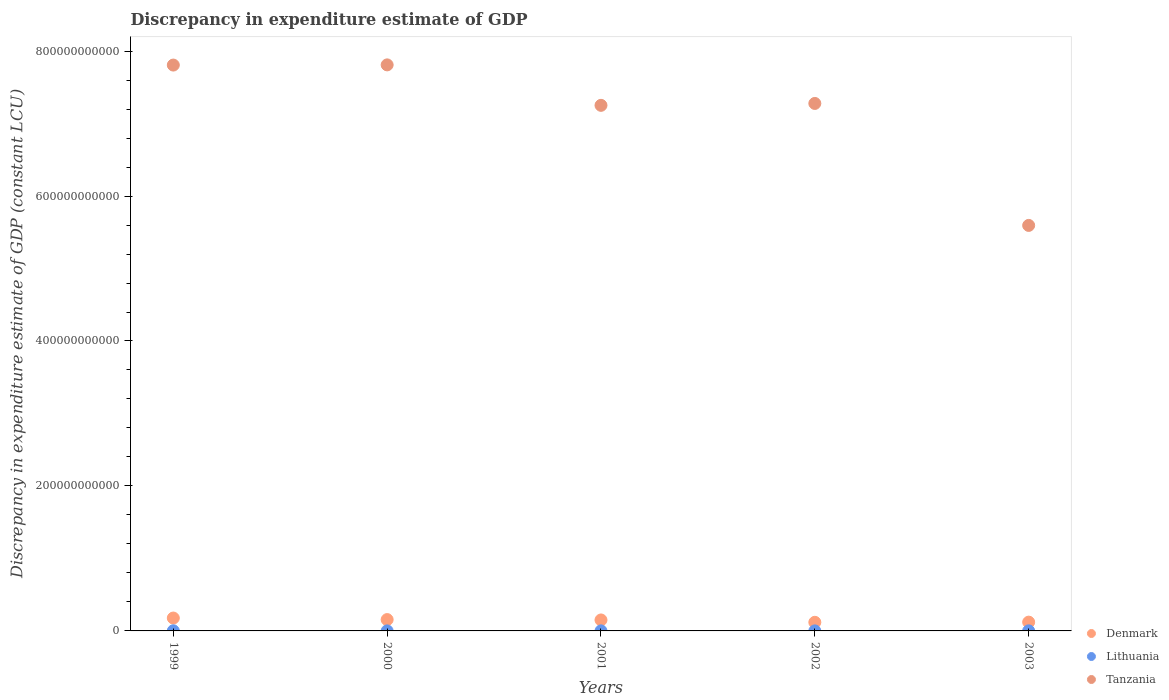How many different coloured dotlines are there?
Keep it short and to the point. 3. Is the number of dotlines equal to the number of legend labels?
Make the answer very short. Yes. What is the discrepancy in expenditure estimate of GDP in Denmark in 2002?
Provide a succinct answer. 1.19e+1. Across all years, what is the maximum discrepancy in expenditure estimate of GDP in Denmark?
Offer a terse response. 1.78e+1. Across all years, what is the minimum discrepancy in expenditure estimate of GDP in Tanzania?
Your response must be concise. 5.59e+11. What is the total discrepancy in expenditure estimate of GDP in Denmark in the graph?
Keep it short and to the point. 7.26e+1. What is the difference between the discrepancy in expenditure estimate of GDP in Lithuania in 1999 and that in 2003?
Your answer should be compact. 8.11e+07. What is the difference between the discrepancy in expenditure estimate of GDP in Denmark in 1999 and the discrepancy in expenditure estimate of GDP in Tanzania in 2001?
Your answer should be very brief. -7.07e+11. What is the average discrepancy in expenditure estimate of GDP in Denmark per year?
Give a very brief answer. 1.45e+1. In the year 2003, what is the difference between the discrepancy in expenditure estimate of GDP in Lithuania and discrepancy in expenditure estimate of GDP in Tanzania?
Offer a terse response. -5.59e+11. In how many years, is the discrepancy in expenditure estimate of GDP in Tanzania greater than 560000000000 LCU?
Provide a short and direct response. 4. What is the ratio of the discrepancy in expenditure estimate of GDP in Lithuania in 2001 to that in 2002?
Your response must be concise. 1.44. Is the discrepancy in expenditure estimate of GDP in Lithuania in 1999 less than that in 2002?
Make the answer very short. No. What is the difference between the highest and the second highest discrepancy in expenditure estimate of GDP in Tanzania?
Your response must be concise. 2.59e+08. What is the difference between the highest and the lowest discrepancy in expenditure estimate of GDP in Tanzania?
Your response must be concise. 2.21e+11. Is the sum of the discrepancy in expenditure estimate of GDP in Lithuania in 2002 and 2003 greater than the maximum discrepancy in expenditure estimate of GDP in Tanzania across all years?
Provide a short and direct response. No. Is it the case that in every year, the sum of the discrepancy in expenditure estimate of GDP in Lithuania and discrepancy in expenditure estimate of GDP in Denmark  is greater than the discrepancy in expenditure estimate of GDP in Tanzania?
Your answer should be compact. No. Does the discrepancy in expenditure estimate of GDP in Denmark monotonically increase over the years?
Ensure brevity in your answer.  No. Is the discrepancy in expenditure estimate of GDP in Denmark strictly greater than the discrepancy in expenditure estimate of GDP in Tanzania over the years?
Your answer should be very brief. No. Is the discrepancy in expenditure estimate of GDP in Tanzania strictly less than the discrepancy in expenditure estimate of GDP in Lithuania over the years?
Your answer should be compact. No. How many dotlines are there?
Offer a terse response. 3. What is the difference between two consecutive major ticks on the Y-axis?
Ensure brevity in your answer.  2.00e+11. Does the graph contain grids?
Make the answer very short. No. What is the title of the graph?
Give a very brief answer. Discrepancy in expenditure estimate of GDP. What is the label or title of the Y-axis?
Your response must be concise. Discrepancy in expenditure estimate of GDP (constant LCU). What is the Discrepancy in expenditure estimate of GDP (constant LCU) of Denmark in 1999?
Give a very brief answer. 1.78e+1. What is the Discrepancy in expenditure estimate of GDP (constant LCU) in Lithuania in 1999?
Give a very brief answer. 1.80e+08. What is the Discrepancy in expenditure estimate of GDP (constant LCU) of Tanzania in 1999?
Give a very brief answer. 7.81e+11. What is the Discrepancy in expenditure estimate of GDP (constant LCU) of Denmark in 2000?
Your answer should be compact. 1.56e+1. What is the Discrepancy in expenditure estimate of GDP (constant LCU) in Lithuania in 2000?
Offer a very short reply. 4.20e+07. What is the Discrepancy in expenditure estimate of GDP (constant LCU) of Tanzania in 2000?
Keep it short and to the point. 7.81e+11. What is the Discrepancy in expenditure estimate of GDP (constant LCU) of Denmark in 2001?
Make the answer very short. 1.51e+1. What is the Discrepancy in expenditure estimate of GDP (constant LCU) of Lithuania in 2001?
Your response must be concise. 6.81e+07. What is the Discrepancy in expenditure estimate of GDP (constant LCU) of Tanzania in 2001?
Give a very brief answer. 7.25e+11. What is the Discrepancy in expenditure estimate of GDP (constant LCU) of Denmark in 2002?
Offer a terse response. 1.19e+1. What is the Discrepancy in expenditure estimate of GDP (constant LCU) in Lithuania in 2002?
Offer a terse response. 4.74e+07. What is the Discrepancy in expenditure estimate of GDP (constant LCU) of Tanzania in 2002?
Your answer should be very brief. 7.28e+11. What is the Discrepancy in expenditure estimate of GDP (constant LCU) of Denmark in 2003?
Ensure brevity in your answer.  1.21e+1. What is the Discrepancy in expenditure estimate of GDP (constant LCU) in Lithuania in 2003?
Your answer should be compact. 9.86e+07. What is the Discrepancy in expenditure estimate of GDP (constant LCU) of Tanzania in 2003?
Your answer should be very brief. 5.59e+11. Across all years, what is the maximum Discrepancy in expenditure estimate of GDP (constant LCU) of Denmark?
Offer a very short reply. 1.78e+1. Across all years, what is the maximum Discrepancy in expenditure estimate of GDP (constant LCU) in Lithuania?
Offer a terse response. 1.80e+08. Across all years, what is the maximum Discrepancy in expenditure estimate of GDP (constant LCU) of Tanzania?
Offer a terse response. 7.81e+11. Across all years, what is the minimum Discrepancy in expenditure estimate of GDP (constant LCU) in Denmark?
Provide a short and direct response. 1.19e+1. Across all years, what is the minimum Discrepancy in expenditure estimate of GDP (constant LCU) in Lithuania?
Give a very brief answer. 4.20e+07. Across all years, what is the minimum Discrepancy in expenditure estimate of GDP (constant LCU) in Tanzania?
Provide a succinct answer. 5.59e+11. What is the total Discrepancy in expenditure estimate of GDP (constant LCU) of Denmark in the graph?
Your answer should be very brief. 7.26e+1. What is the total Discrepancy in expenditure estimate of GDP (constant LCU) in Lithuania in the graph?
Offer a terse response. 4.36e+08. What is the total Discrepancy in expenditure estimate of GDP (constant LCU) of Tanzania in the graph?
Provide a short and direct response. 3.57e+12. What is the difference between the Discrepancy in expenditure estimate of GDP (constant LCU) of Denmark in 1999 and that in 2000?
Provide a succinct answer. 2.12e+09. What is the difference between the Discrepancy in expenditure estimate of GDP (constant LCU) of Lithuania in 1999 and that in 2000?
Your response must be concise. 1.38e+08. What is the difference between the Discrepancy in expenditure estimate of GDP (constant LCU) in Tanzania in 1999 and that in 2000?
Your answer should be compact. -2.59e+08. What is the difference between the Discrepancy in expenditure estimate of GDP (constant LCU) in Denmark in 1999 and that in 2001?
Provide a succinct answer. 2.63e+09. What is the difference between the Discrepancy in expenditure estimate of GDP (constant LCU) of Lithuania in 1999 and that in 2001?
Give a very brief answer. 1.12e+08. What is the difference between the Discrepancy in expenditure estimate of GDP (constant LCU) of Tanzania in 1999 and that in 2001?
Offer a very short reply. 5.56e+1. What is the difference between the Discrepancy in expenditure estimate of GDP (constant LCU) of Denmark in 1999 and that in 2002?
Provide a short and direct response. 5.87e+09. What is the difference between the Discrepancy in expenditure estimate of GDP (constant LCU) in Lithuania in 1999 and that in 2002?
Keep it short and to the point. 1.32e+08. What is the difference between the Discrepancy in expenditure estimate of GDP (constant LCU) of Tanzania in 1999 and that in 2002?
Offer a very short reply. 5.30e+1. What is the difference between the Discrepancy in expenditure estimate of GDP (constant LCU) in Denmark in 1999 and that in 2003?
Make the answer very short. 5.64e+09. What is the difference between the Discrepancy in expenditure estimate of GDP (constant LCU) in Lithuania in 1999 and that in 2003?
Your answer should be very brief. 8.11e+07. What is the difference between the Discrepancy in expenditure estimate of GDP (constant LCU) of Tanzania in 1999 and that in 2003?
Provide a short and direct response. 2.21e+11. What is the difference between the Discrepancy in expenditure estimate of GDP (constant LCU) of Denmark in 2000 and that in 2001?
Keep it short and to the point. 5.18e+08. What is the difference between the Discrepancy in expenditure estimate of GDP (constant LCU) in Lithuania in 2000 and that in 2001?
Make the answer very short. -2.60e+07. What is the difference between the Discrepancy in expenditure estimate of GDP (constant LCU) in Tanzania in 2000 and that in 2001?
Keep it short and to the point. 5.58e+1. What is the difference between the Discrepancy in expenditure estimate of GDP (constant LCU) in Denmark in 2000 and that in 2002?
Make the answer very short. 3.76e+09. What is the difference between the Discrepancy in expenditure estimate of GDP (constant LCU) in Lithuania in 2000 and that in 2002?
Provide a short and direct response. -5.33e+06. What is the difference between the Discrepancy in expenditure estimate of GDP (constant LCU) of Tanzania in 2000 and that in 2002?
Offer a terse response. 5.32e+1. What is the difference between the Discrepancy in expenditure estimate of GDP (constant LCU) of Denmark in 2000 and that in 2003?
Give a very brief answer. 3.53e+09. What is the difference between the Discrepancy in expenditure estimate of GDP (constant LCU) of Lithuania in 2000 and that in 2003?
Your answer should be very brief. -5.65e+07. What is the difference between the Discrepancy in expenditure estimate of GDP (constant LCU) of Tanzania in 2000 and that in 2003?
Your answer should be compact. 2.21e+11. What is the difference between the Discrepancy in expenditure estimate of GDP (constant LCU) of Denmark in 2001 and that in 2002?
Your answer should be very brief. 3.24e+09. What is the difference between the Discrepancy in expenditure estimate of GDP (constant LCU) of Lithuania in 2001 and that in 2002?
Your response must be concise. 2.07e+07. What is the difference between the Discrepancy in expenditure estimate of GDP (constant LCU) of Tanzania in 2001 and that in 2002?
Offer a very short reply. -2.62e+09. What is the difference between the Discrepancy in expenditure estimate of GDP (constant LCU) of Denmark in 2001 and that in 2003?
Your response must be concise. 3.01e+09. What is the difference between the Discrepancy in expenditure estimate of GDP (constant LCU) of Lithuania in 2001 and that in 2003?
Provide a short and direct response. -3.05e+07. What is the difference between the Discrepancy in expenditure estimate of GDP (constant LCU) in Tanzania in 2001 and that in 2003?
Make the answer very short. 1.66e+11. What is the difference between the Discrepancy in expenditure estimate of GDP (constant LCU) in Denmark in 2002 and that in 2003?
Your answer should be compact. -2.29e+08. What is the difference between the Discrepancy in expenditure estimate of GDP (constant LCU) in Lithuania in 2002 and that in 2003?
Offer a terse response. -5.12e+07. What is the difference between the Discrepancy in expenditure estimate of GDP (constant LCU) in Tanzania in 2002 and that in 2003?
Your answer should be very brief. 1.68e+11. What is the difference between the Discrepancy in expenditure estimate of GDP (constant LCU) in Denmark in 1999 and the Discrepancy in expenditure estimate of GDP (constant LCU) in Lithuania in 2000?
Make the answer very short. 1.77e+1. What is the difference between the Discrepancy in expenditure estimate of GDP (constant LCU) of Denmark in 1999 and the Discrepancy in expenditure estimate of GDP (constant LCU) of Tanzania in 2000?
Provide a succinct answer. -7.63e+11. What is the difference between the Discrepancy in expenditure estimate of GDP (constant LCU) of Lithuania in 1999 and the Discrepancy in expenditure estimate of GDP (constant LCU) of Tanzania in 2000?
Provide a short and direct response. -7.81e+11. What is the difference between the Discrepancy in expenditure estimate of GDP (constant LCU) in Denmark in 1999 and the Discrepancy in expenditure estimate of GDP (constant LCU) in Lithuania in 2001?
Your answer should be very brief. 1.77e+1. What is the difference between the Discrepancy in expenditure estimate of GDP (constant LCU) in Denmark in 1999 and the Discrepancy in expenditure estimate of GDP (constant LCU) in Tanzania in 2001?
Your answer should be very brief. -7.07e+11. What is the difference between the Discrepancy in expenditure estimate of GDP (constant LCU) of Lithuania in 1999 and the Discrepancy in expenditure estimate of GDP (constant LCU) of Tanzania in 2001?
Provide a succinct answer. -7.25e+11. What is the difference between the Discrepancy in expenditure estimate of GDP (constant LCU) of Denmark in 1999 and the Discrepancy in expenditure estimate of GDP (constant LCU) of Lithuania in 2002?
Make the answer very short. 1.77e+1. What is the difference between the Discrepancy in expenditure estimate of GDP (constant LCU) in Denmark in 1999 and the Discrepancy in expenditure estimate of GDP (constant LCU) in Tanzania in 2002?
Offer a terse response. -7.10e+11. What is the difference between the Discrepancy in expenditure estimate of GDP (constant LCU) of Lithuania in 1999 and the Discrepancy in expenditure estimate of GDP (constant LCU) of Tanzania in 2002?
Your answer should be very brief. -7.28e+11. What is the difference between the Discrepancy in expenditure estimate of GDP (constant LCU) of Denmark in 1999 and the Discrepancy in expenditure estimate of GDP (constant LCU) of Lithuania in 2003?
Give a very brief answer. 1.77e+1. What is the difference between the Discrepancy in expenditure estimate of GDP (constant LCU) of Denmark in 1999 and the Discrepancy in expenditure estimate of GDP (constant LCU) of Tanzania in 2003?
Ensure brevity in your answer.  -5.42e+11. What is the difference between the Discrepancy in expenditure estimate of GDP (constant LCU) in Lithuania in 1999 and the Discrepancy in expenditure estimate of GDP (constant LCU) in Tanzania in 2003?
Offer a very short reply. -5.59e+11. What is the difference between the Discrepancy in expenditure estimate of GDP (constant LCU) of Denmark in 2000 and the Discrepancy in expenditure estimate of GDP (constant LCU) of Lithuania in 2001?
Offer a very short reply. 1.56e+1. What is the difference between the Discrepancy in expenditure estimate of GDP (constant LCU) in Denmark in 2000 and the Discrepancy in expenditure estimate of GDP (constant LCU) in Tanzania in 2001?
Make the answer very short. -7.09e+11. What is the difference between the Discrepancy in expenditure estimate of GDP (constant LCU) of Lithuania in 2000 and the Discrepancy in expenditure estimate of GDP (constant LCU) of Tanzania in 2001?
Make the answer very short. -7.25e+11. What is the difference between the Discrepancy in expenditure estimate of GDP (constant LCU) of Denmark in 2000 and the Discrepancy in expenditure estimate of GDP (constant LCU) of Lithuania in 2002?
Your response must be concise. 1.56e+1. What is the difference between the Discrepancy in expenditure estimate of GDP (constant LCU) in Denmark in 2000 and the Discrepancy in expenditure estimate of GDP (constant LCU) in Tanzania in 2002?
Give a very brief answer. -7.12e+11. What is the difference between the Discrepancy in expenditure estimate of GDP (constant LCU) in Lithuania in 2000 and the Discrepancy in expenditure estimate of GDP (constant LCU) in Tanzania in 2002?
Give a very brief answer. -7.28e+11. What is the difference between the Discrepancy in expenditure estimate of GDP (constant LCU) in Denmark in 2000 and the Discrepancy in expenditure estimate of GDP (constant LCU) in Lithuania in 2003?
Give a very brief answer. 1.55e+1. What is the difference between the Discrepancy in expenditure estimate of GDP (constant LCU) of Denmark in 2000 and the Discrepancy in expenditure estimate of GDP (constant LCU) of Tanzania in 2003?
Keep it short and to the point. -5.44e+11. What is the difference between the Discrepancy in expenditure estimate of GDP (constant LCU) in Lithuania in 2000 and the Discrepancy in expenditure estimate of GDP (constant LCU) in Tanzania in 2003?
Your response must be concise. -5.59e+11. What is the difference between the Discrepancy in expenditure estimate of GDP (constant LCU) of Denmark in 2001 and the Discrepancy in expenditure estimate of GDP (constant LCU) of Lithuania in 2002?
Offer a terse response. 1.51e+1. What is the difference between the Discrepancy in expenditure estimate of GDP (constant LCU) in Denmark in 2001 and the Discrepancy in expenditure estimate of GDP (constant LCU) in Tanzania in 2002?
Provide a short and direct response. -7.13e+11. What is the difference between the Discrepancy in expenditure estimate of GDP (constant LCU) in Lithuania in 2001 and the Discrepancy in expenditure estimate of GDP (constant LCU) in Tanzania in 2002?
Offer a terse response. -7.28e+11. What is the difference between the Discrepancy in expenditure estimate of GDP (constant LCU) in Denmark in 2001 and the Discrepancy in expenditure estimate of GDP (constant LCU) in Lithuania in 2003?
Offer a very short reply. 1.50e+1. What is the difference between the Discrepancy in expenditure estimate of GDP (constant LCU) of Denmark in 2001 and the Discrepancy in expenditure estimate of GDP (constant LCU) of Tanzania in 2003?
Keep it short and to the point. -5.44e+11. What is the difference between the Discrepancy in expenditure estimate of GDP (constant LCU) in Lithuania in 2001 and the Discrepancy in expenditure estimate of GDP (constant LCU) in Tanzania in 2003?
Your answer should be very brief. -5.59e+11. What is the difference between the Discrepancy in expenditure estimate of GDP (constant LCU) in Denmark in 2002 and the Discrepancy in expenditure estimate of GDP (constant LCU) in Lithuania in 2003?
Your response must be concise. 1.18e+1. What is the difference between the Discrepancy in expenditure estimate of GDP (constant LCU) in Denmark in 2002 and the Discrepancy in expenditure estimate of GDP (constant LCU) in Tanzania in 2003?
Offer a very short reply. -5.48e+11. What is the difference between the Discrepancy in expenditure estimate of GDP (constant LCU) of Lithuania in 2002 and the Discrepancy in expenditure estimate of GDP (constant LCU) of Tanzania in 2003?
Provide a succinct answer. -5.59e+11. What is the average Discrepancy in expenditure estimate of GDP (constant LCU) in Denmark per year?
Provide a short and direct response. 1.45e+1. What is the average Discrepancy in expenditure estimate of GDP (constant LCU) of Lithuania per year?
Offer a terse response. 8.71e+07. What is the average Discrepancy in expenditure estimate of GDP (constant LCU) in Tanzania per year?
Your answer should be very brief. 7.15e+11. In the year 1999, what is the difference between the Discrepancy in expenditure estimate of GDP (constant LCU) of Denmark and Discrepancy in expenditure estimate of GDP (constant LCU) of Lithuania?
Ensure brevity in your answer.  1.76e+1. In the year 1999, what is the difference between the Discrepancy in expenditure estimate of GDP (constant LCU) of Denmark and Discrepancy in expenditure estimate of GDP (constant LCU) of Tanzania?
Your response must be concise. -7.63e+11. In the year 1999, what is the difference between the Discrepancy in expenditure estimate of GDP (constant LCU) of Lithuania and Discrepancy in expenditure estimate of GDP (constant LCU) of Tanzania?
Ensure brevity in your answer.  -7.81e+11. In the year 2000, what is the difference between the Discrepancy in expenditure estimate of GDP (constant LCU) in Denmark and Discrepancy in expenditure estimate of GDP (constant LCU) in Lithuania?
Ensure brevity in your answer.  1.56e+1. In the year 2000, what is the difference between the Discrepancy in expenditure estimate of GDP (constant LCU) of Denmark and Discrepancy in expenditure estimate of GDP (constant LCU) of Tanzania?
Your answer should be very brief. -7.65e+11. In the year 2000, what is the difference between the Discrepancy in expenditure estimate of GDP (constant LCU) of Lithuania and Discrepancy in expenditure estimate of GDP (constant LCU) of Tanzania?
Give a very brief answer. -7.81e+11. In the year 2001, what is the difference between the Discrepancy in expenditure estimate of GDP (constant LCU) of Denmark and Discrepancy in expenditure estimate of GDP (constant LCU) of Lithuania?
Your answer should be compact. 1.51e+1. In the year 2001, what is the difference between the Discrepancy in expenditure estimate of GDP (constant LCU) in Denmark and Discrepancy in expenditure estimate of GDP (constant LCU) in Tanzania?
Offer a very short reply. -7.10e+11. In the year 2001, what is the difference between the Discrepancy in expenditure estimate of GDP (constant LCU) in Lithuania and Discrepancy in expenditure estimate of GDP (constant LCU) in Tanzania?
Keep it short and to the point. -7.25e+11. In the year 2002, what is the difference between the Discrepancy in expenditure estimate of GDP (constant LCU) of Denmark and Discrepancy in expenditure estimate of GDP (constant LCU) of Lithuania?
Provide a succinct answer. 1.18e+1. In the year 2002, what is the difference between the Discrepancy in expenditure estimate of GDP (constant LCU) in Denmark and Discrepancy in expenditure estimate of GDP (constant LCU) in Tanzania?
Provide a succinct answer. -7.16e+11. In the year 2002, what is the difference between the Discrepancy in expenditure estimate of GDP (constant LCU) of Lithuania and Discrepancy in expenditure estimate of GDP (constant LCU) of Tanzania?
Make the answer very short. -7.28e+11. In the year 2003, what is the difference between the Discrepancy in expenditure estimate of GDP (constant LCU) of Denmark and Discrepancy in expenditure estimate of GDP (constant LCU) of Lithuania?
Give a very brief answer. 1.20e+1. In the year 2003, what is the difference between the Discrepancy in expenditure estimate of GDP (constant LCU) of Denmark and Discrepancy in expenditure estimate of GDP (constant LCU) of Tanzania?
Make the answer very short. -5.47e+11. In the year 2003, what is the difference between the Discrepancy in expenditure estimate of GDP (constant LCU) of Lithuania and Discrepancy in expenditure estimate of GDP (constant LCU) of Tanzania?
Give a very brief answer. -5.59e+11. What is the ratio of the Discrepancy in expenditure estimate of GDP (constant LCU) in Denmark in 1999 to that in 2000?
Provide a succinct answer. 1.14. What is the ratio of the Discrepancy in expenditure estimate of GDP (constant LCU) of Lithuania in 1999 to that in 2000?
Provide a short and direct response. 4.27. What is the ratio of the Discrepancy in expenditure estimate of GDP (constant LCU) of Tanzania in 1999 to that in 2000?
Ensure brevity in your answer.  1. What is the ratio of the Discrepancy in expenditure estimate of GDP (constant LCU) in Denmark in 1999 to that in 2001?
Ensure brevity in your answer.  1.17. What is the ratio of the Discrepancy in expenditure estimate of GDP (constant LCU) in Lithuania in 1999 to that in 2001?
Your answer should be very brief. 2.64. What is the ratio of the Discrepancy in expenditure estimate of GDP (constant LCU) of Tanzania in 1999 to that in 2001?
Provide a succinct answer. 1.08. What is the ratio of the Discrepancy in expenditure estimate of GDP (constant LCU) of Denmark in 1999 to that in 2002?
Ensure brevity in your answer.  1.49. What is the ratio of the Discrepancy in expenditure estimate of GDP (constant LCU) in Lithuania in 1999 to that in 2002?
Offer a very short reply. 3.79. What is the ratio of the Discrepancy in expenditure estimate of GDP (constant LCU) of Tanzania in 1999 to that in 2002?
Your response must be concise. 1.07. What is the ratio of the Discrepancy in expenditure estimate of GDP (constant LCU) of Denmark in 1999 to that in 2003?
Your answer should be compact. 1.47. What is the ratio of the Discrepancy in expenditure estimate of GDP (constant LCU) of Lithuania in 1999 to that in 2003?
Your answer should be very brief. 1.82. What is the ratio of the Discrepancy in expenditure estimate of GDP (constant LCU) of Tanzania in 1999 to that in 2003?
Your answer should be compact. 1.4. What is the ratio of the Discrepancy in expenditure estimate of GDP (constant LCU) of Denmark in 2000 to that in 2001?
Your answer should be compact. 1.03. What is the ratio of the Discrepancy in expenditure estimate of GDP (constant LCU) in Lithuania in 2000 to that in 2001?
Provide a succinct answer. 0.62. What is the ratio of the Discrepancy in expenditure estimate of GDP (constant LCU) of Tanzania in 2000 to that in 2001?
Your answer should be compact. 1.08. What is the ratio of the Discrepancy in expenditure estimate of GDP (constant LCU) of Denmark in 2000 to that in 2002?
Ensure brevity in your answer.  1.32. What is the ratio of the Discrepancy in expenditure estimate of GDP (constant LCU) of Lithuania in 2000 to that in 2002?
Make the answer very short. 0.89. What is the ratio of the Discrepancy in expenditure estimate of GDP (constant LCU) of Tanzania in 2000 to that in 2002?
Your answer should be very brief. 1.07. What is the ratio of the Discrepancy in expenditure estimate of GDP (constant LCU) in Denmark in 2000 to that in 2003?
Offer a very short reply. 1.29. What is the ratio of the Discrepancy in expenditure estimate of GDP (constant LCU) in Lithuania in 2000 to that in 2003?
Offer a terse response. 0.43. What is the ratio of the Discrepancy in expenditure estimate of GDP (constant LCU) in Tanzania in 2000 to that in 2003?
Provide a succinct answer. 1.4. What is the ratio of the Discrepancy in expenditure estimate of GDP (constant LCU) of Denmark in 2001 to that in 2002?
Make the answer very short. 1.27. What is the ratio of the Discrepancy in expenditure estimate of GDP (constant LCU) of Lithuania in 2001 to that in 2002?
Your answer should be very brief. 1.44. What is the ratio of the Discrepancy in expenditure estimate of GDP (constant LCU) in Tanzania in 2001 to that in 2002?
Give a very brief answer. 1. What is the ratio of the Discrepancy in expenditure estimate of GDP (constant LCU) of Denmark in 2001 to that in 2003?
Provide a succinct answer. 1.25. What is the ratio of the Discrepancy in expenditure estimate of GDP (constant LCU) of Lithuania in 2001 to that in 2003?
Make the answer very short. 0.69. What is the ratio of the Discrepancy in expenditure estimate of GDP (constant LCU) in Tanzania in 2001 to that in 2003?
Make the answer very short. 1.3. What is the ratio of the Discrepancy in expenditure estimate of GDP (constant LCU) of Denmark in 2002 to that in 2003?
Give a very brief answer. 0.98. What is the ratio of the Discrepancy in expenditure estimate of GDP (constant LCU) in Lithuania in 2002 to that in 2003?
Offer a terse response. 0.48. What is the ratio of the Discrepancy in expenditure estimate of GDP (constant LCU) in Tanzania in 2002 to that in 2003?
Offer a very short reply. 1.3. What is the difference between the highest and the second highest Discrepancy in expenditure estimate of GDP (constant LCU) of Denmark?
Ensure brevity in your answer.  2.12e+09. What is the difference between the highest and the second highest Discrepancy in expenditure estimate of GDP (constant LCU) of Lithuania?
Give a very brief answer. 8.11e+07. What is the difference between the highest and the second highest Discrepancy in expenditure estimate of GDP (constant LCU) of Tanzania?
Your answer should be compact. 2.59e+08. What is the difference between the highest and the lowest Discrepancy in expenditure estimate of GDP (constant LCU) in Denmark?
Offer a very short reply. 5.87e+09. What is the difference between the highest and the lowest Discrepancy in expenditure estimate of GDP (constant LCU) of Lithuania?
Offer a very short reply. 1.38e+08. What is the difference between the highest and the lowest Discrepancy in expenditure estimate of GDP (constant LCU) of Tanzania?
Offer a very short reply. 2.21e+11. 